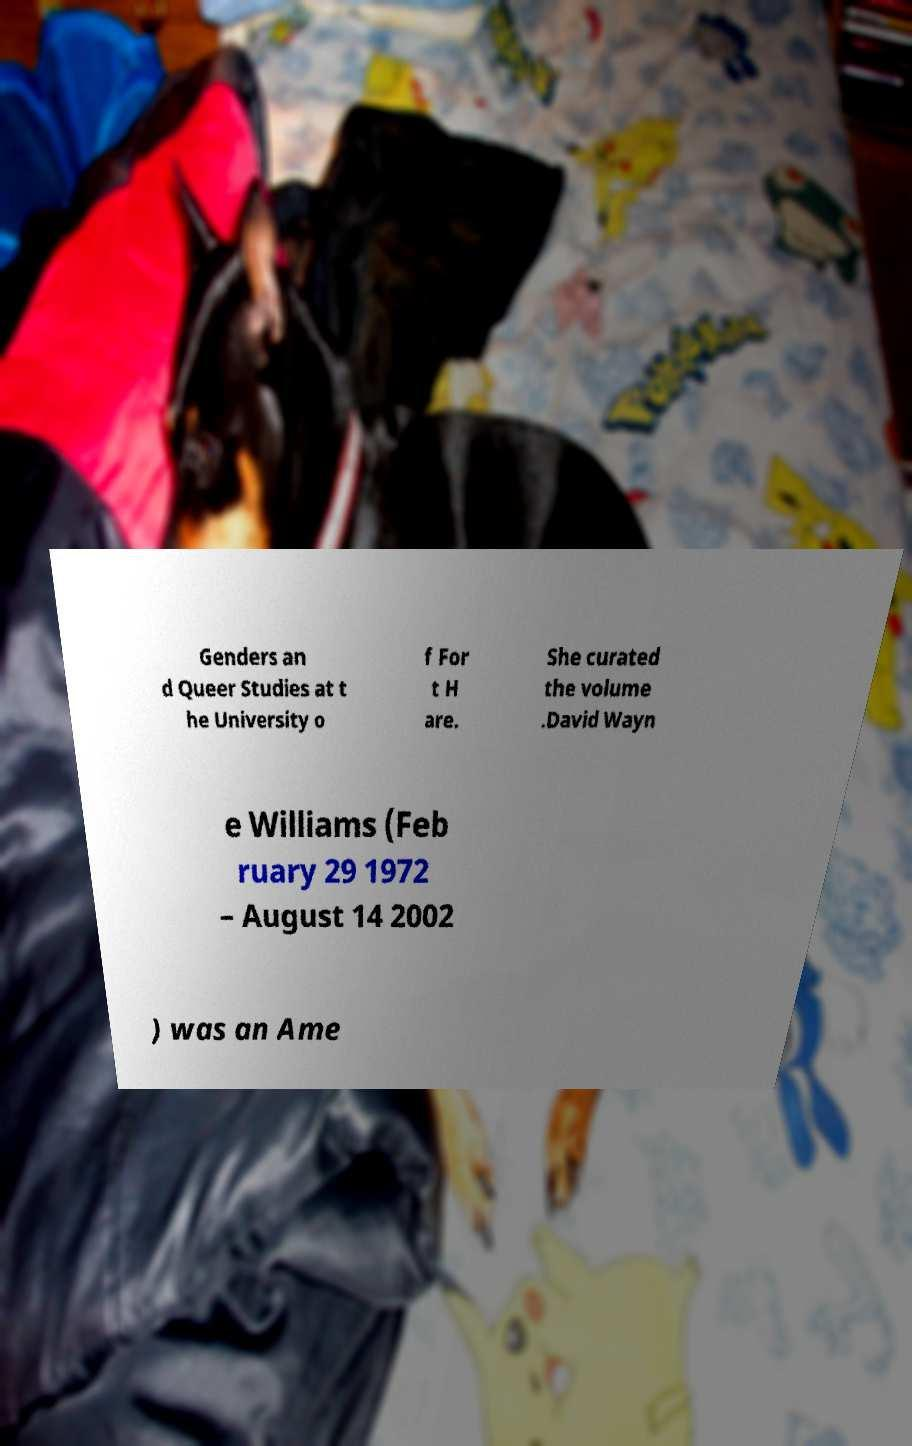For documentation purposes, I need the text within this image transcribed. Could you provide that? Genders an d Queer Studies at t he University o f For t H are. She curated the volume .David Wayn e Williams (Feb ruary 29 1972 – August 14 2002 ) was an Ame 